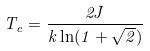<formula> <loc_0><loc_0><loc_500><loc_500>T _ { c } = \frac { 2 J } { k \ln ( 1 + \sqrt { 2 } ) }</formula> 